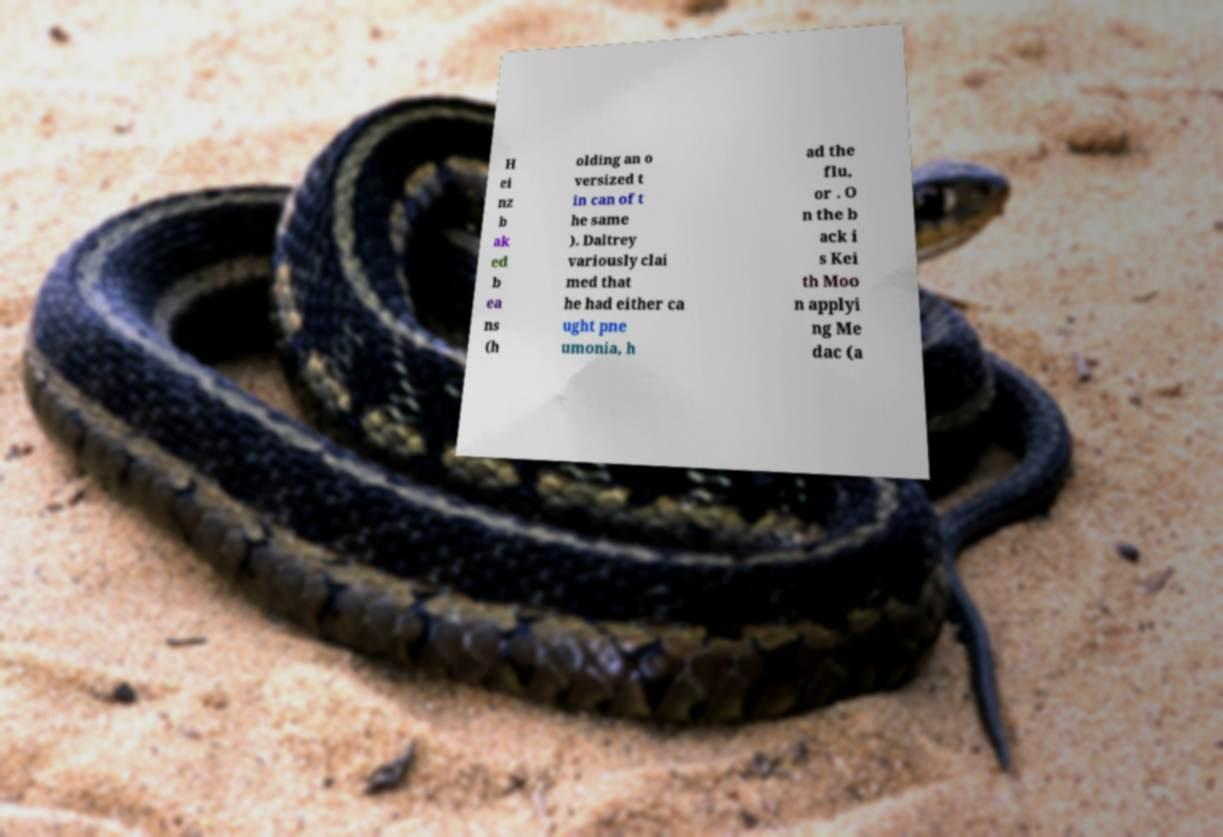What messages or text are displayed in this image? I need them in a readable, typed format. H ei nz b ak ed b ea ns (h olding an o versized t in can of t he same ). Daltrey variously clai med that he had either ca ught pne umonia, h ad the flu, or . O n the b ack i s Kei th Moo n applyi ng Me dac (a 